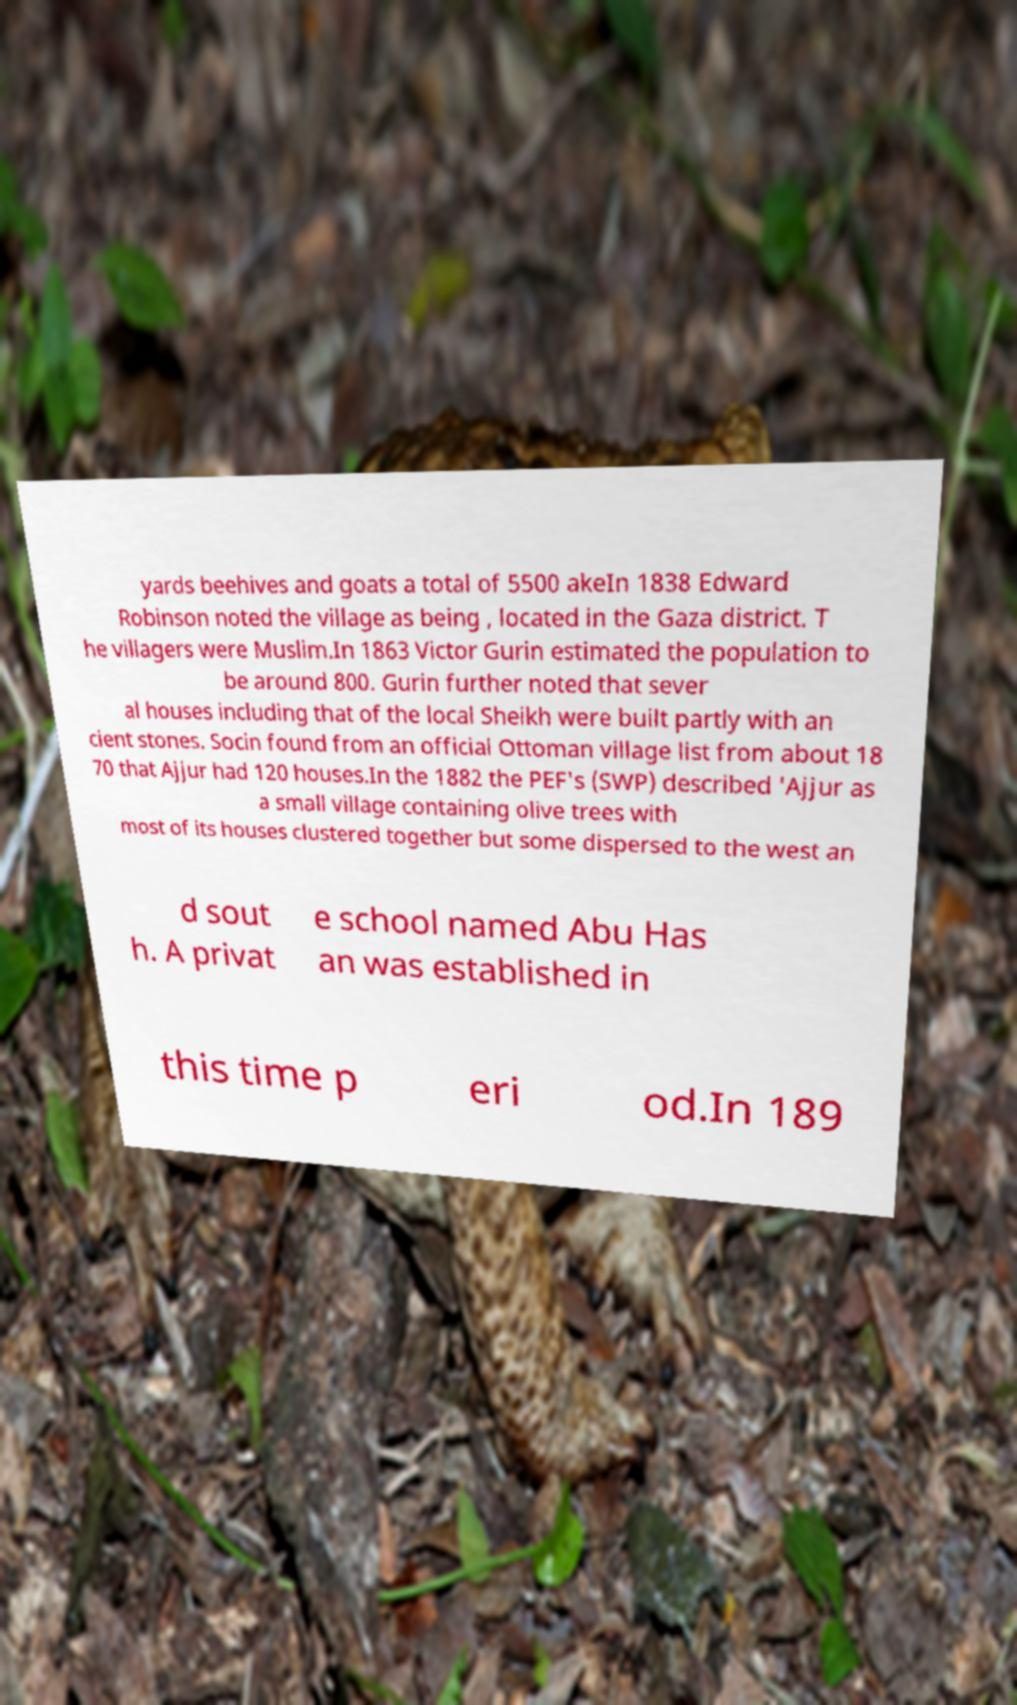Can you read and provide the text displayed in the image?This photo seems to have some interesting text. Can you extract and type it out for me? yards beehives and goats a total of 5500 akeIn 1838 Edward Robinson noted the village as being , located in the Gaza district. T he villagers were Muslim.In 1863 Victor Gurin estimated the population to be around 800. Gurin further noted that sever al houses including that of the local Sheikh were built partly with an cient stones. Socin found from an official Ottoman village list from about 18 70 that Ajjur had 120 houses.In the 1882 the PEF's (SWP) described 'Ajjur as a small village containing olive trees with most of its houses clustered together but some dispersed to the west an d sout h. A privat e school named Abu Has an was established in this time p eri od.In 189 